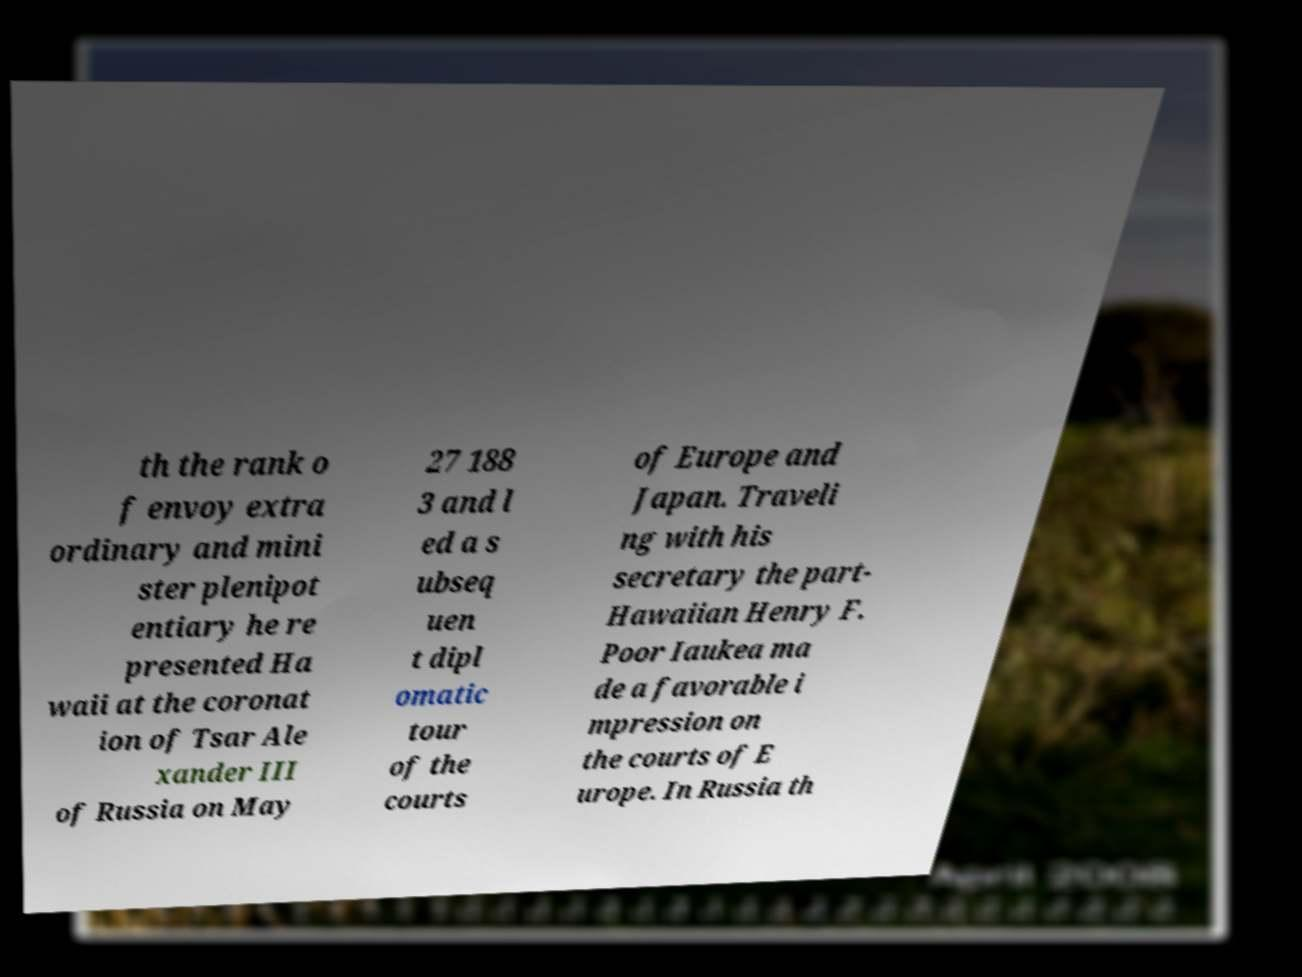Please read and relay the text visible in this image. What does it say? th the rank o f envoy extra ordinary and mini ster plenipot entiary he re presented Ha waii at the coronat ion of Tsar Ale xander III of Russia on May 27 188 3 and l ed a s ubseq uen t dipl omatic tour of the courts of Europe and Japan. Traveli ng with his secretary the part- Hawaiian Henry F. Poor Iaukea ma de a favorable i mpression on the courts of E urope. In Russia th 